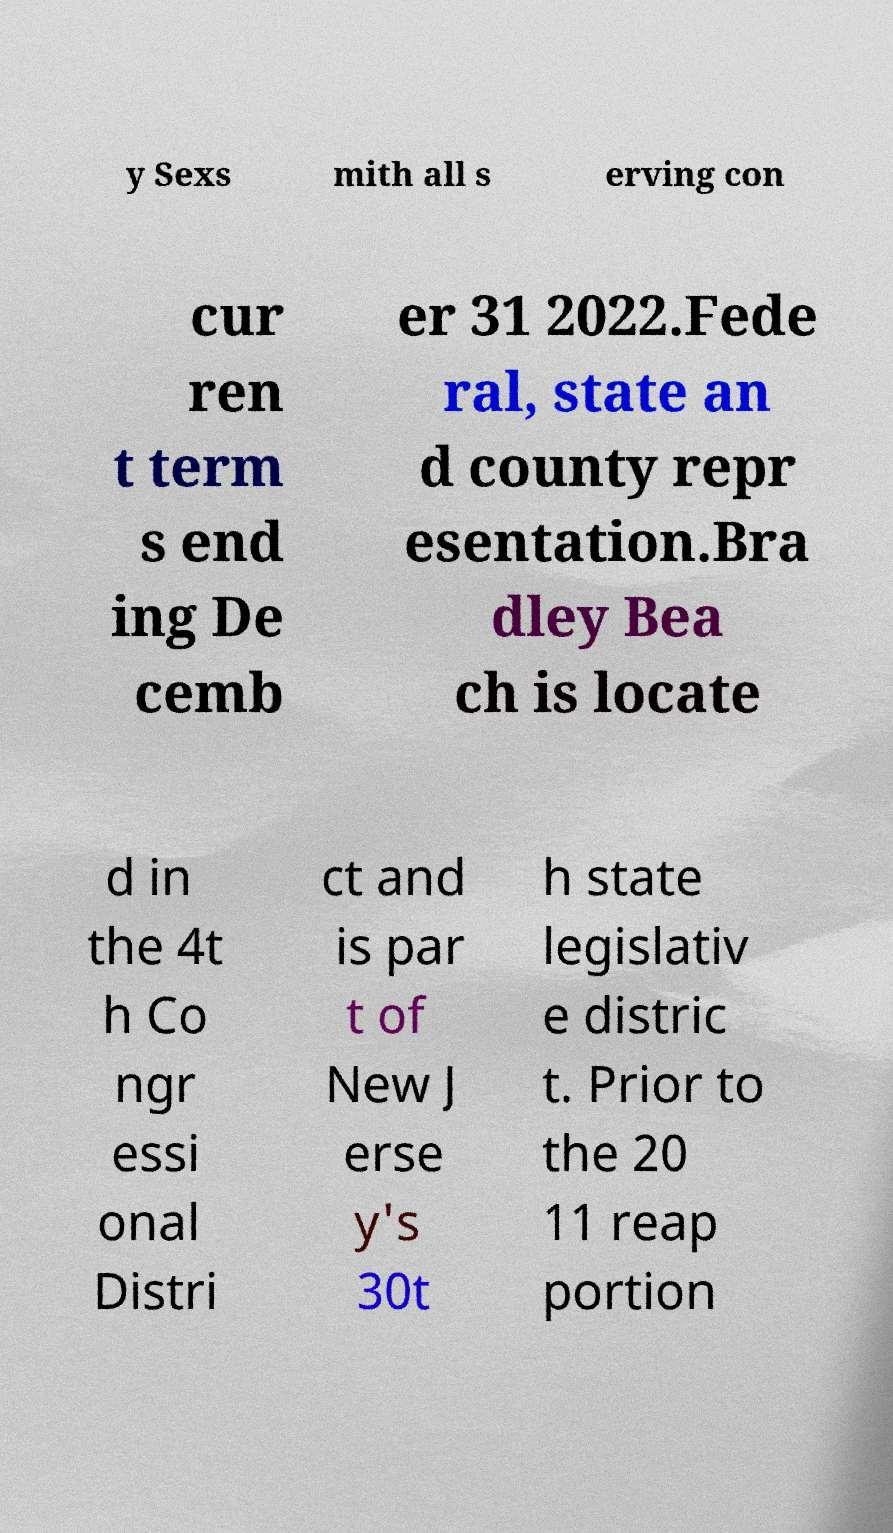Could you assist in decoding the text presented in this image and type it out clearly? y Sexs mith all s erving con cur ren t term s end ing De cemb er 31 2022.Fede ral, state an d county repr esentation.Bra dley Bea ch is locate d in the 4t h Co ngr essi onal Distri ct and is par t of New J erse y's 30t h state legislativ e distric t. Prior to the 20 11 reap portion 